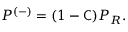<formula> <loc_0><loc_0><loc_500><loc_500>P ^ { ( - ) } = ( 1 - { C } ) P _ { R } .</formula> 